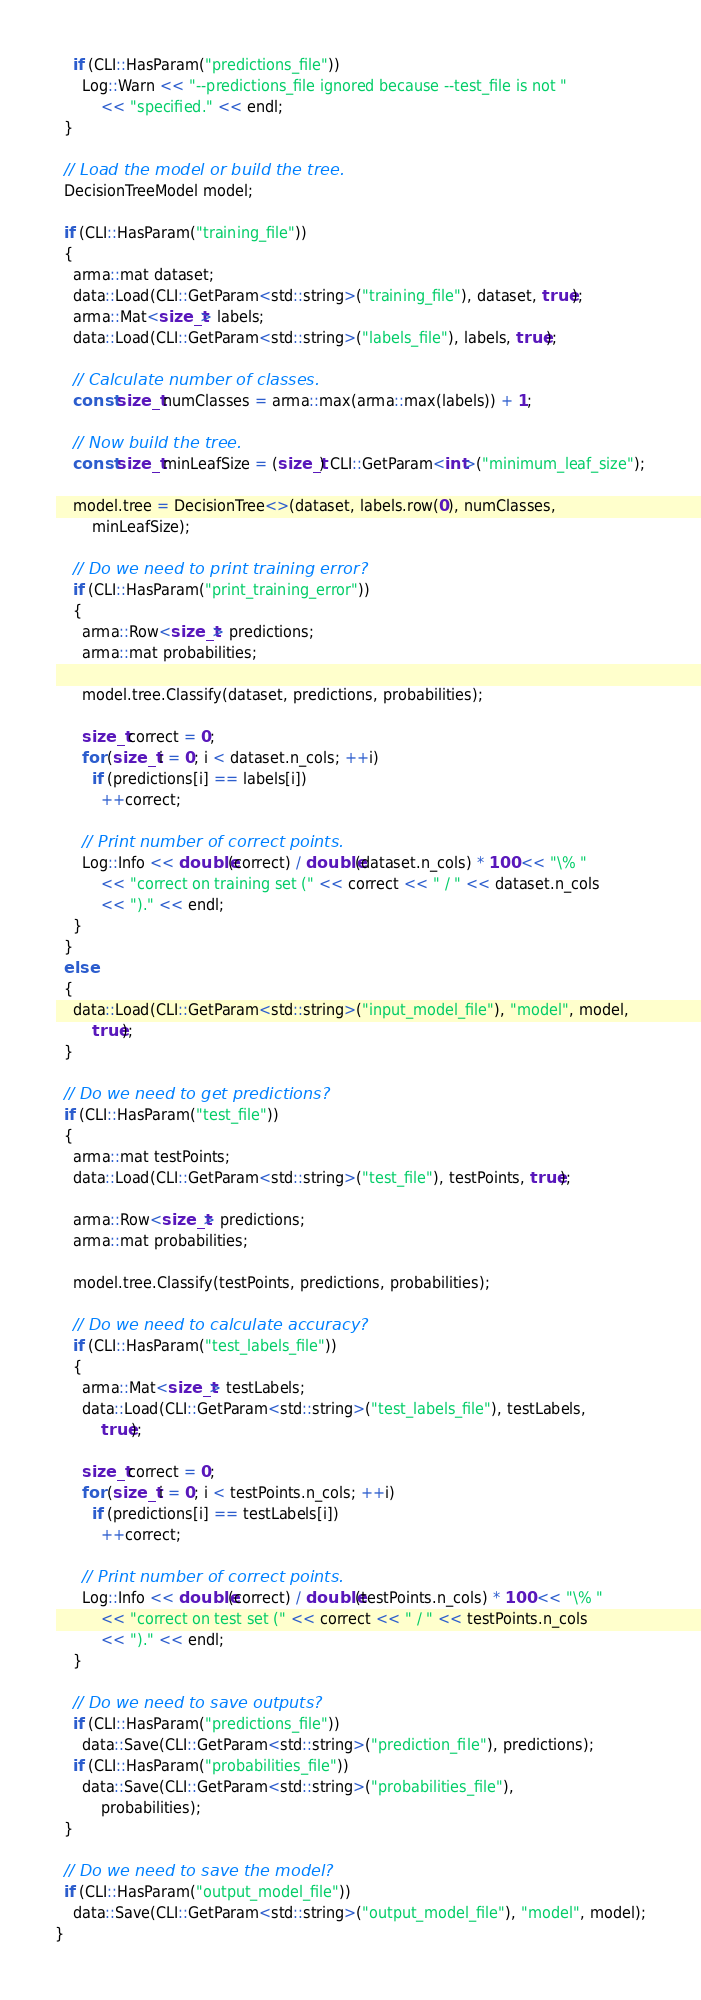<code> <loc_0><loc_0><loc_500><loc_500><_C++_>    if (CLI::HasParam("predictions_file"))
      Log::Warn << "--predictions_file ignored because --test_file is not "
          << "specified." << endl;
  }

  // Load the model or build the tree.
  DecisionTreeModel model;

  if (CLI::HasParam("training_file"))
  {
    arma::mat dataset;
    data::Load(CLI::GetParam<std::string>("training_file"), dataset, true);
    arma::Mat<size_t> labels;
    data::Load(CLI::GetParam<std::string>("labels_file"), labels, true);

    // Calculate number of classes.
    const size_t numClasses = arma::max(arma::max(labels)) + 1;

    // Now build the tree.
    const size_t minLeafSize = (size_t) CLI::GetParam<int>("minimum_leaf_size");

    model.tree = DecisionTree<>(dataset, labels.row(0), numClasses,
        minLeafSize);

    // Do we need to print training error?
    if (CLI::HasParam("print_training_error"))
    {
      arma::Row<size_t> predictions;
      arma::mat probabilities;

      model.tree.Classify(dataset, predictions, probabilities);

      size_t correct = 0;
      for (size_t i = 0; i < dataset.n_cols; ++i)
        if (predictions[i] == labels[i])
          ++correct;

      // Print number of correct points.
      Log::Info << double(correct) / double(dataset.n_cols) * 100 << "\% "
          << "correct on training set (" << correct << " / " << dataset.n_cols
          << ")." << endl;
    }
  }
  else
  {
    data::Load(CLI::GetParam<std::string>("input_model_file"), "model", model,
        true);
  }

  // Do we need to get predictions?
  if (CLI::HasParam("test_file"))
  {
    arma::mat testPoints;
    data::Load(CLI::GetParam<std::string>("test_file"), testPoints, true);

    arma::Row<size_t> predictions;
    arma::mat probabilities;

    model.tree.Classify(testPoints, predictions, probabilities);

    // Do we need to calculate accuracy?
    if (CLI::HasParam("test_labels_file"))
    {
      arma::Mat<size_t> testLabels;
      data::Load(CLI::GetParam<std::string>("test_labels_file"), testLabels,
          true);

      size_t correct = 0;
      for (size_t i = 0; i < testPoints.n_cols; ++i)
        if (predictions[i] == testLabels[i])
          ++correct;

      // Print number of correct points.
      Log::Info << double(correct) / double(testPoints.n_cols) * 100 << "\% "
          << "correct on test set (" << correct << " / " << testPoints.n_cols
          << ")." << endl;
    }

    // Do we need to save outputs?
    if (CLI::HasParam("predictions_file"))
      data::Save(CLI::GetParam<std::string>("prediction_file"), predictions);
    if (CLI::HasParam("probabilities_file"))
      data::Save(CLI::GetParam<std::string>("probabilities_file"),
          probabilities);
  }

  // Do we need to save the model?
  if (CLI::HasParam("output_model_file"))
    data::Save(CLI::GetParam<std::string>("output_model_file"), "model", model);
}
</code> 